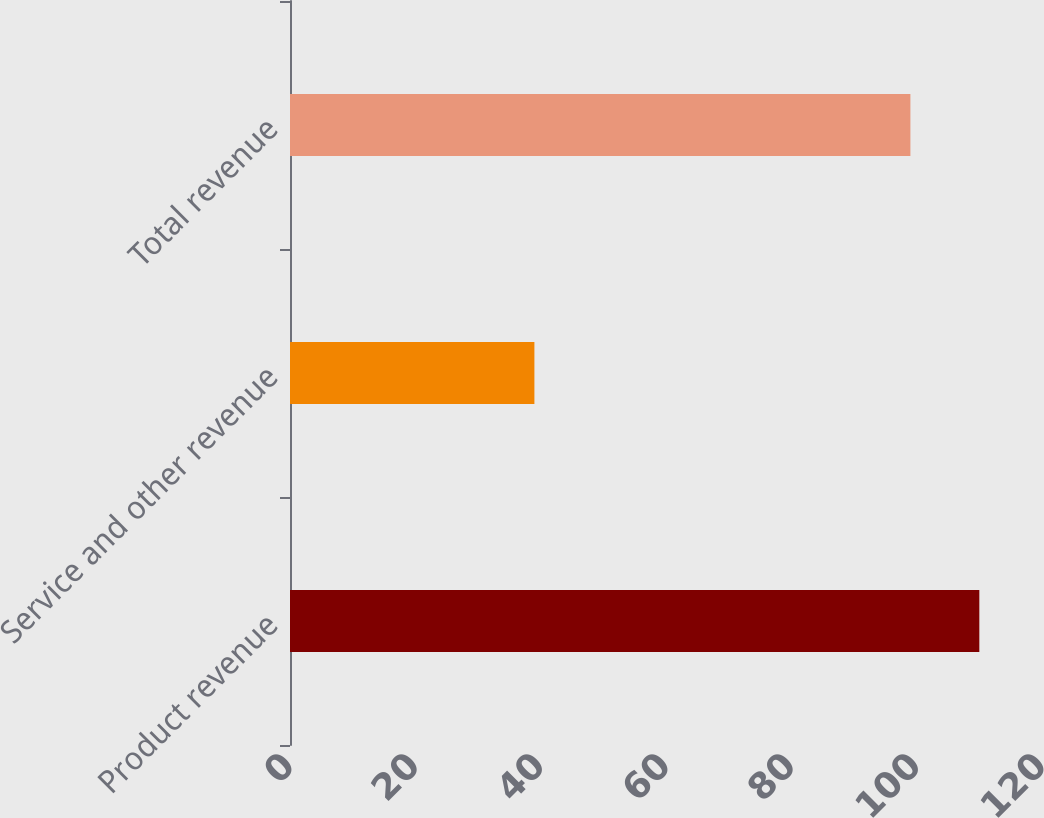Convert chart to OTSL. <chart><loc_0><loc_0><loc_500><loc_500><bar_chart><fcel>Product revenue<fcel>Service and other revenue<fcel>Total revenue<nl><fcel>110<fcel>39<fcel>99<nl></chart> 